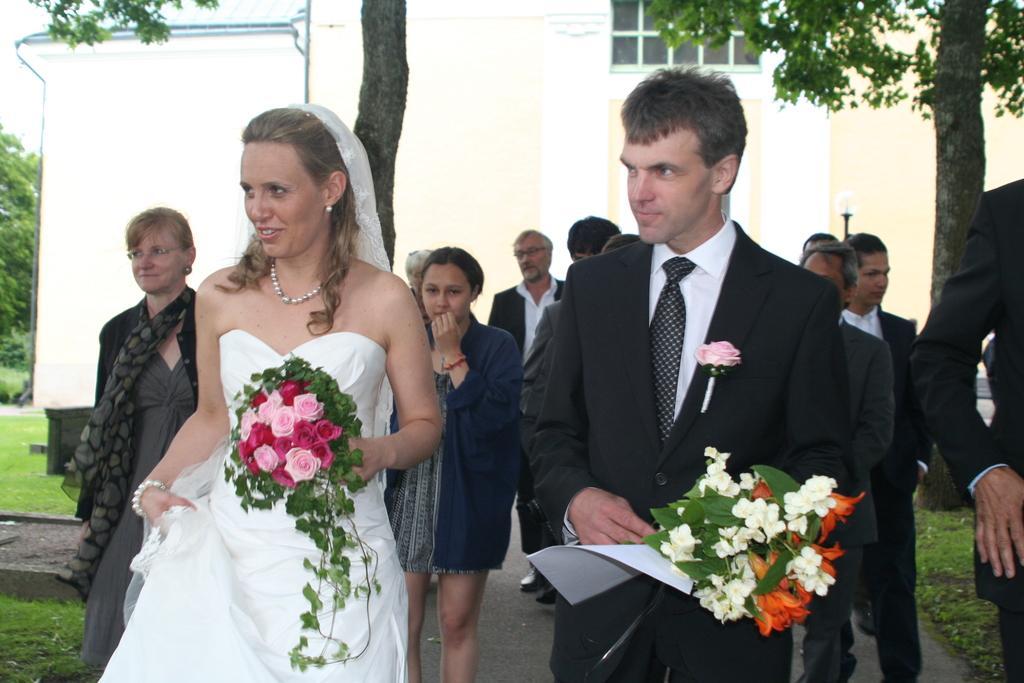Could you give a brief overview of what you see in this image? In this image there is a bride and groom walking on the road along with flowers, behind them there are a group of people walking and also there is a building and tree, grass on the ground. 